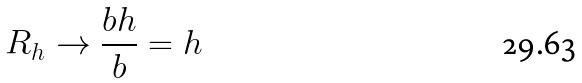<formula> <loc_0><loc_0><loc_500><loc_500>R _ { h } \rightarrow \frac { b h } { b } = h</formula> 